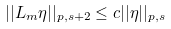Convert formula to latex. <formula><loc_0><loc_0><loc_500><loc_500>| | L _ { m } \eta | | _ { p , s + 2 } \leq c | | \eta | | _ { p , s }</formula> 